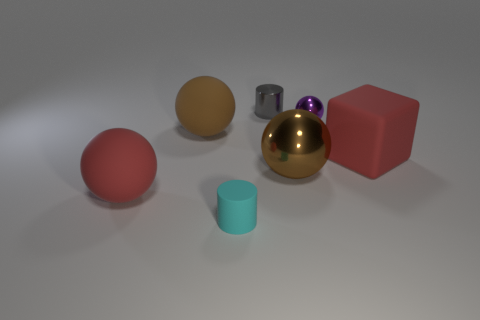What is the color of the big metal ball?
Offer a very short reply. Brown. What shape is the large thing that is the same color as the matte cube?
Your answer should be compact. Sphere. What is the color of the other cylinder that is the same size as the cyan rubber cylinder?
Give a very brief answer. Gray. How many matte things are cyan balls or tiny cyan cylinders?
Keep it short and to the point. 1. What number of objects are on the right side of the red sphere and behind the cyan cylinder?
Provide a short and direct response. 5. How many other objects are the same size as the gray thing?
Your answer should be compact. 2. Is the size of the rubber sphere that is in front of the block the same as the cylinder in front of the small metal cylinder?
Offer a terse response. No. What number of objects are big red metal blocks or metallic spheres that are in front of the big red block?
Keep it short and to the point. 1. How big is the brown object that is right of the small cyan object?
Give a very brief answer. Large. Is the number of big red matte spheres that are behind the gray shiny cylinder less than the number of large matte objects to the left of the big brown matte ball?
Provide a short and direct response. Yes. 